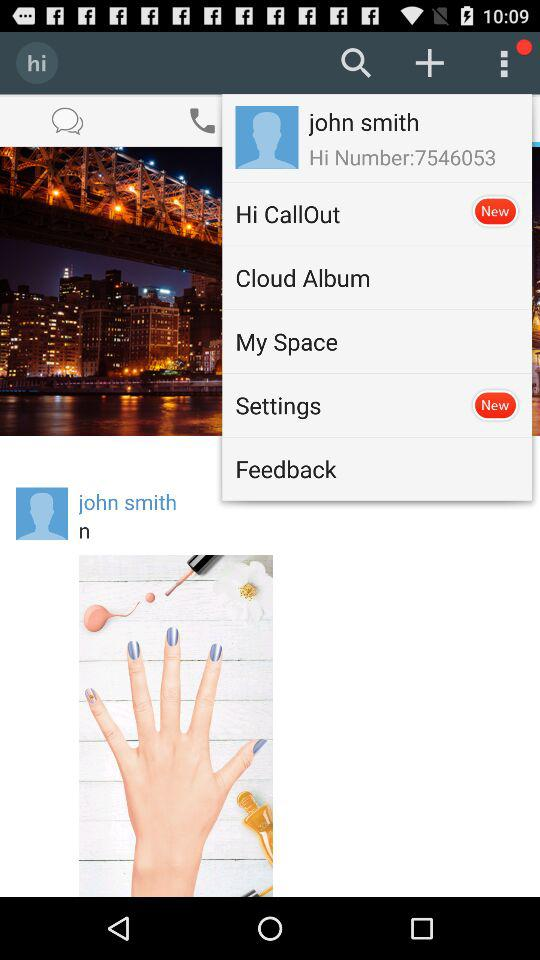What is the number? The number is 7546053. 